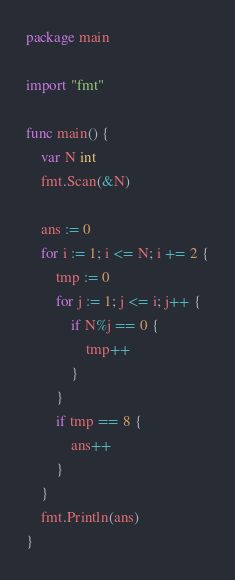<code> <loc_0><loc_0><loc_500><loc_500><_Go_>package main

import "fmt"

func main() {
	var N int
	fmt.Scan(&N)

	ans := 0
	for i := 1; i <= N; i += 2 {
		tmp := 0
		for j := 1; j <= i; j++ {
			if N%j == 0 {
				tmp++
			}
		}
		if tmp == 8 {
			ans++
		}
	}
	fmt.Println(ans)
}
</code> 